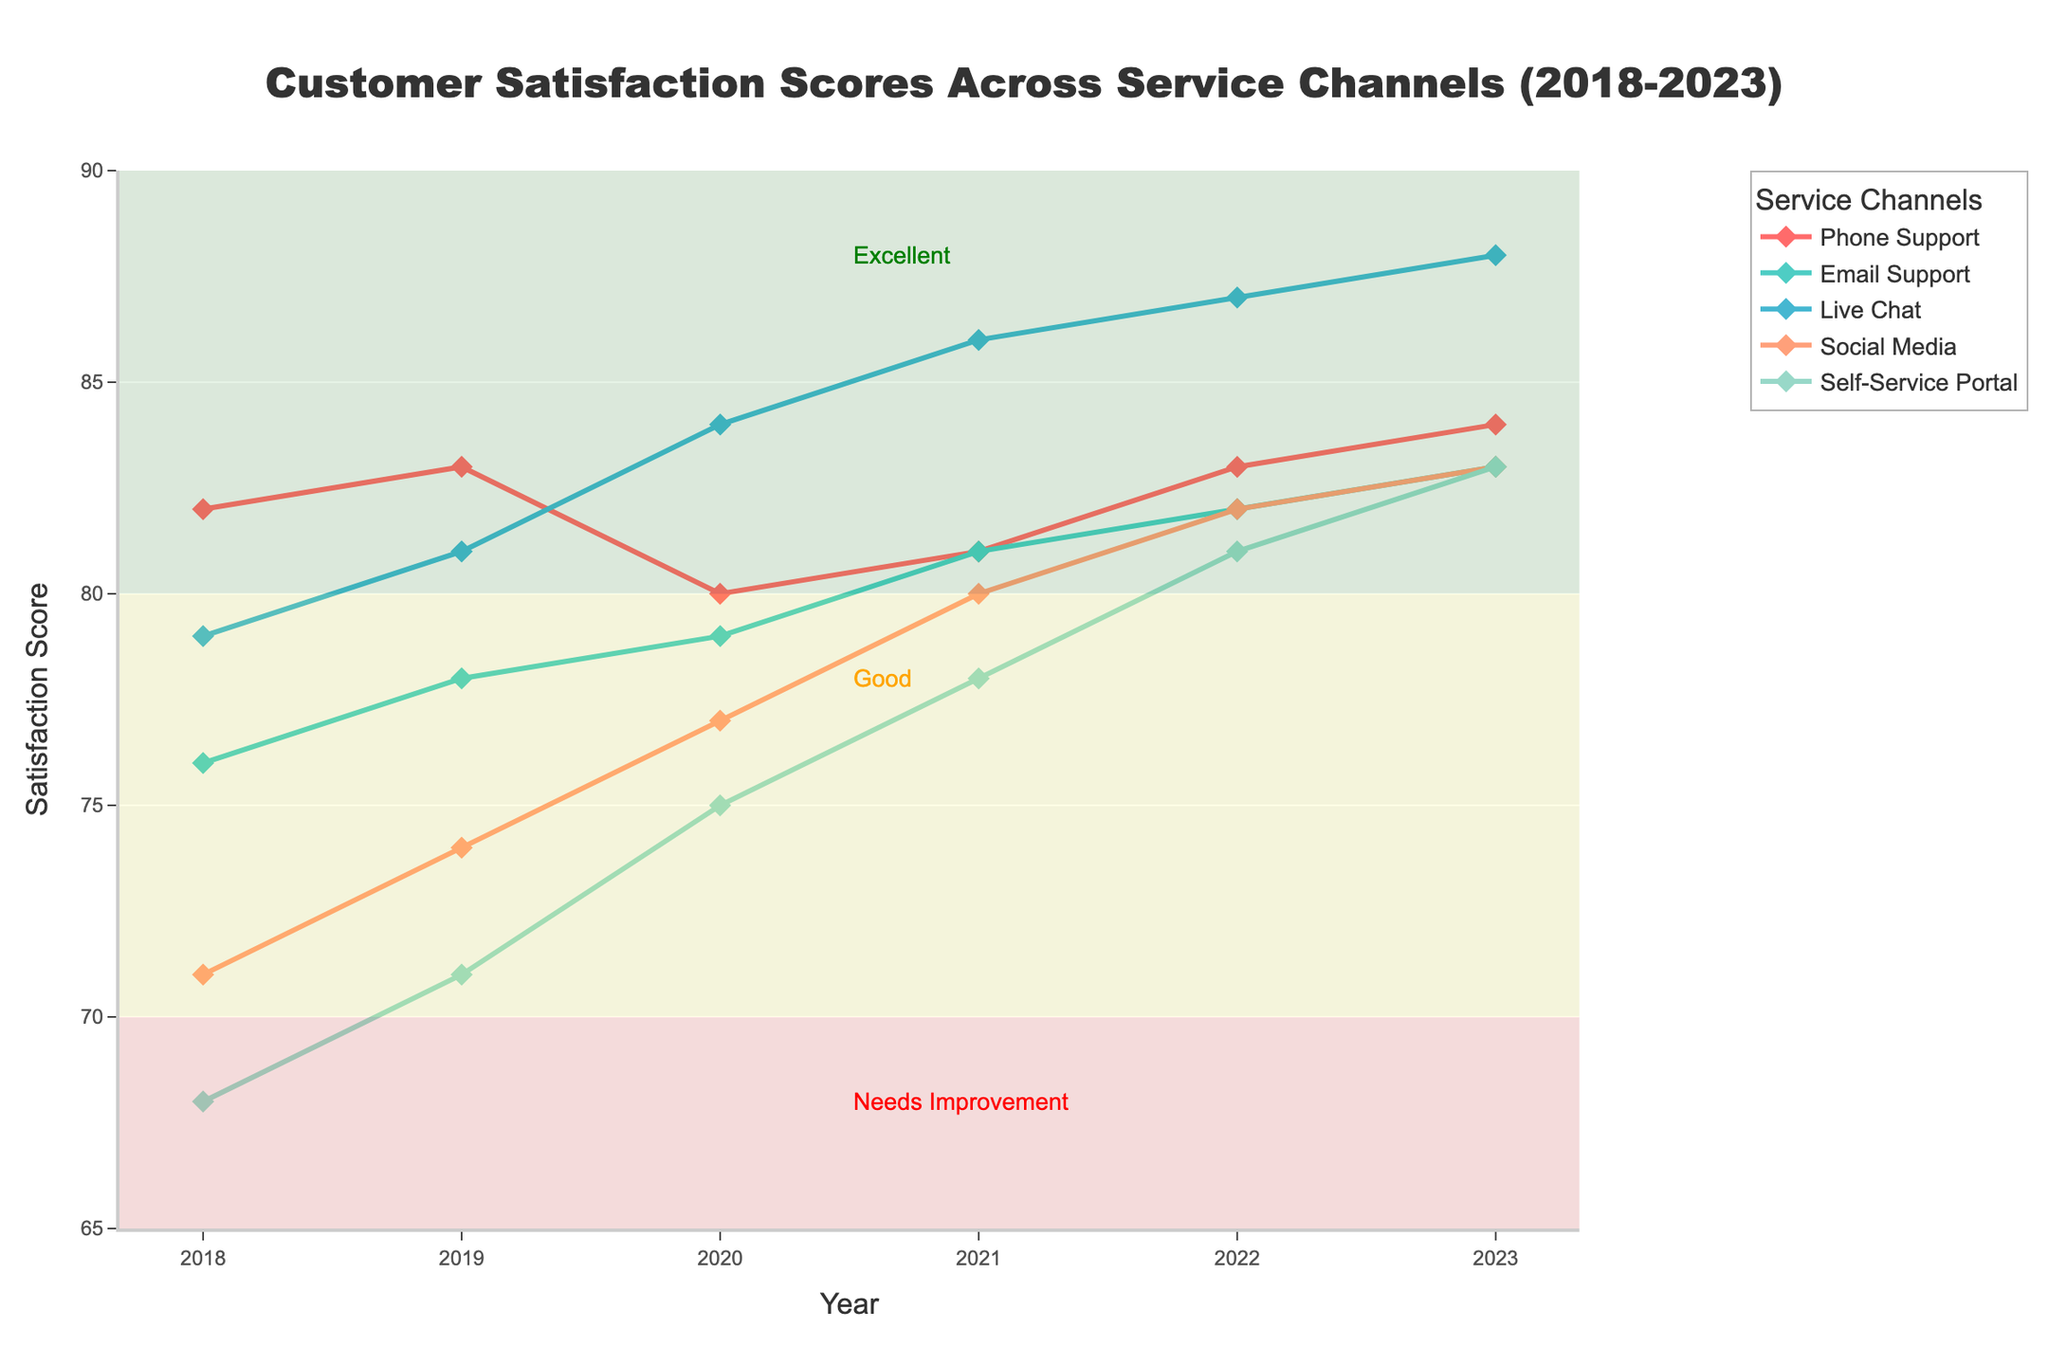What is the average satisfaction score for Phone Support over the years 2018 to 2023? To find the average score, sum all satisfaction scores for Phone Support from 2018 to 2023 and divide by the number of years (6). (82 + 83 + 80 + 81 + 83 + 84) / 6 = 493 / 6 ≈ 82.17
Answer: 82.17 Which service channel had the highest satisfaction score in 2023? Look at the plot for the year 2023 and check which service channel's score reaches the highest point. The highest score in 2023 is 88 for Live Chat.
Answer: Live Chat How did the satisfaction score for Social Media change from 2021 to 2023? Check the satisfaction scores for Social Media in the years 2021 and 2023. In 2021, it was 80, and in 2023, it was 83. The change is 83 - 80 = 3.
Answer: Increased by 3 Which service channel had the most consistent increase in satisfaction scores from 2018 to 2023? Examine the trends of all service channels from 2018 to 2023. The most consistent increase is where the line is steadily rising without major dips. The Self-Service Portal shows a consistent rise from 68 in 2018 to 83 in 2023.
Answer: Self-Service Portal How many service channels had satisfaction scores in the 'Excellent' range (above 85) by 2023? Identify the scores for each service channel in 2023. Live Chat has 88, which is above 85. No other channels have scores above 85. Only one channel fits this criterion.
Answer: 1 Compare the trend of Email Support and Live Chat satisfaction scores from 2018 to 2023. Which had a steeper increase? To compare trends, look at the slope of the lines. Email Support increased from 76 to 83 (+7), and Live Chat from 79 to 88 (+9) over the same period. Live Chat had a steeper increase.
Answer: Live Chat What were the satisfaction score differences between Phone Support and the Self-Service Portal in 2018 and 2023? For Phone Support and Self-Service Portal in 2018: 82 - 68 = 14. In 2023: 84 - 83 = 1.
Answer: 14 (2018), 1 (2023) In which year did Email Support surpass Phone Support in satisfaction scores, and by how much? Identify when Email Support's score first exceeded Phone Support's score. This happened in 2020 with Email Support at 79 and Phone Support at 80. Email Support had one more satisfaction score than Phone Support.
Answer: 2020, by 1 